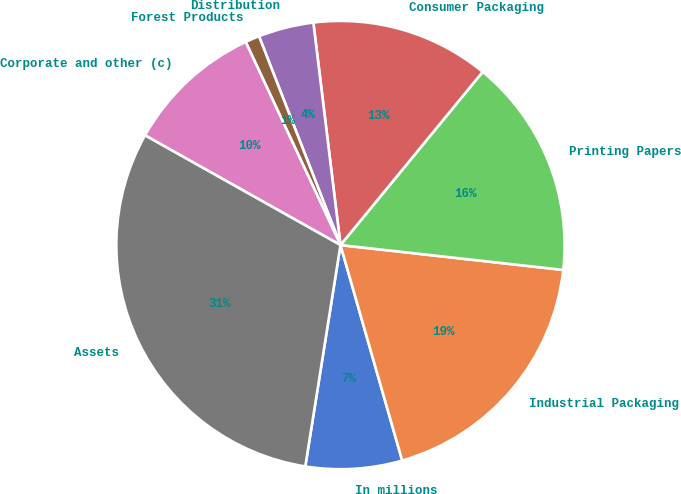<chart> <loc_0><loc_0><loc_500><loc_500><pie_chart><fcel>In millions<fcel>Industrial Packaging<fcel>Printing Papers<fcel>Consumer Packaging<fcel>Distribution<fcel>Forest Products<fcel>Corporate and other (c)<fcel>Assets<nl><fcel>6.95%<fcel>18.79%<fcel>15.83%<fcel>12.87%<fcel>3.99%<fcel>1.03%<fcel>9.91%<fcel>30.63%<nl></chart> 